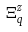<formula> <loc_0><loc_0><loc_500><loc_500>\Xi _ { q } ^ { z }</formula> 